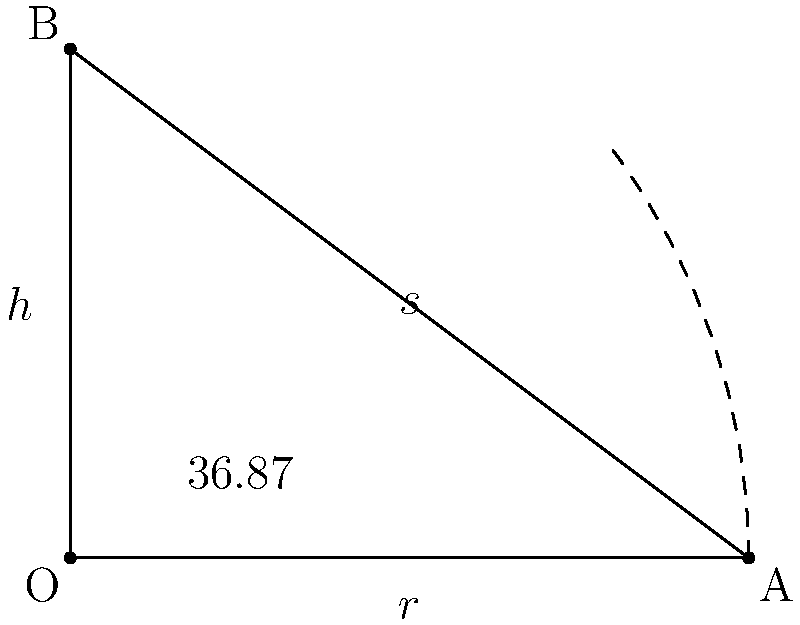You want to create a conical display stand for your pastries. The stand has a radius of 40 cm at the base and a slant height of 50 cm. Using trigonometric functions, calculate the volume of the conical stand to the nearest cubic centimeter. (Use $\pi = 3.14159$) To find the volume of the cone, we need to use the formula:

$$V = \frac{1}{3}\pi r^2 h$$

Where $r$ is the radius of the base and $h$ is the height of the cone.

We are given:
- Radius ($r$) = 40 cm
- Slant height ($s$) = 50 cm

Step 1: Find the height ($h$) of the cone using the Pythagorean theorem:
$$s^2 = r^2 + h^2$$
$$50^2 = 40^2 + h^2$$
$$2500 = 1600 + h^2$$
$$h^2 = 900$$
$$h = 30 \text{ cm}$$

Step 2: Calculate the volume using the formula:
$$V = \frac{1}{3}\pi r^2 h$$
$$V = \frac{1}{3} \times 3.14159 \times 40^2 \times 30$$
$$V = \frac{1}{3} \times 3.14159 \times 1600 \times 30$$
$$V = 50,265.44 \text{ cm}^3$$

Step 3: Round to the nearest cubic centimeter:
$$V \approx 50,265 \text{ cm}^3$$
Answer: 50,265 cm³ 